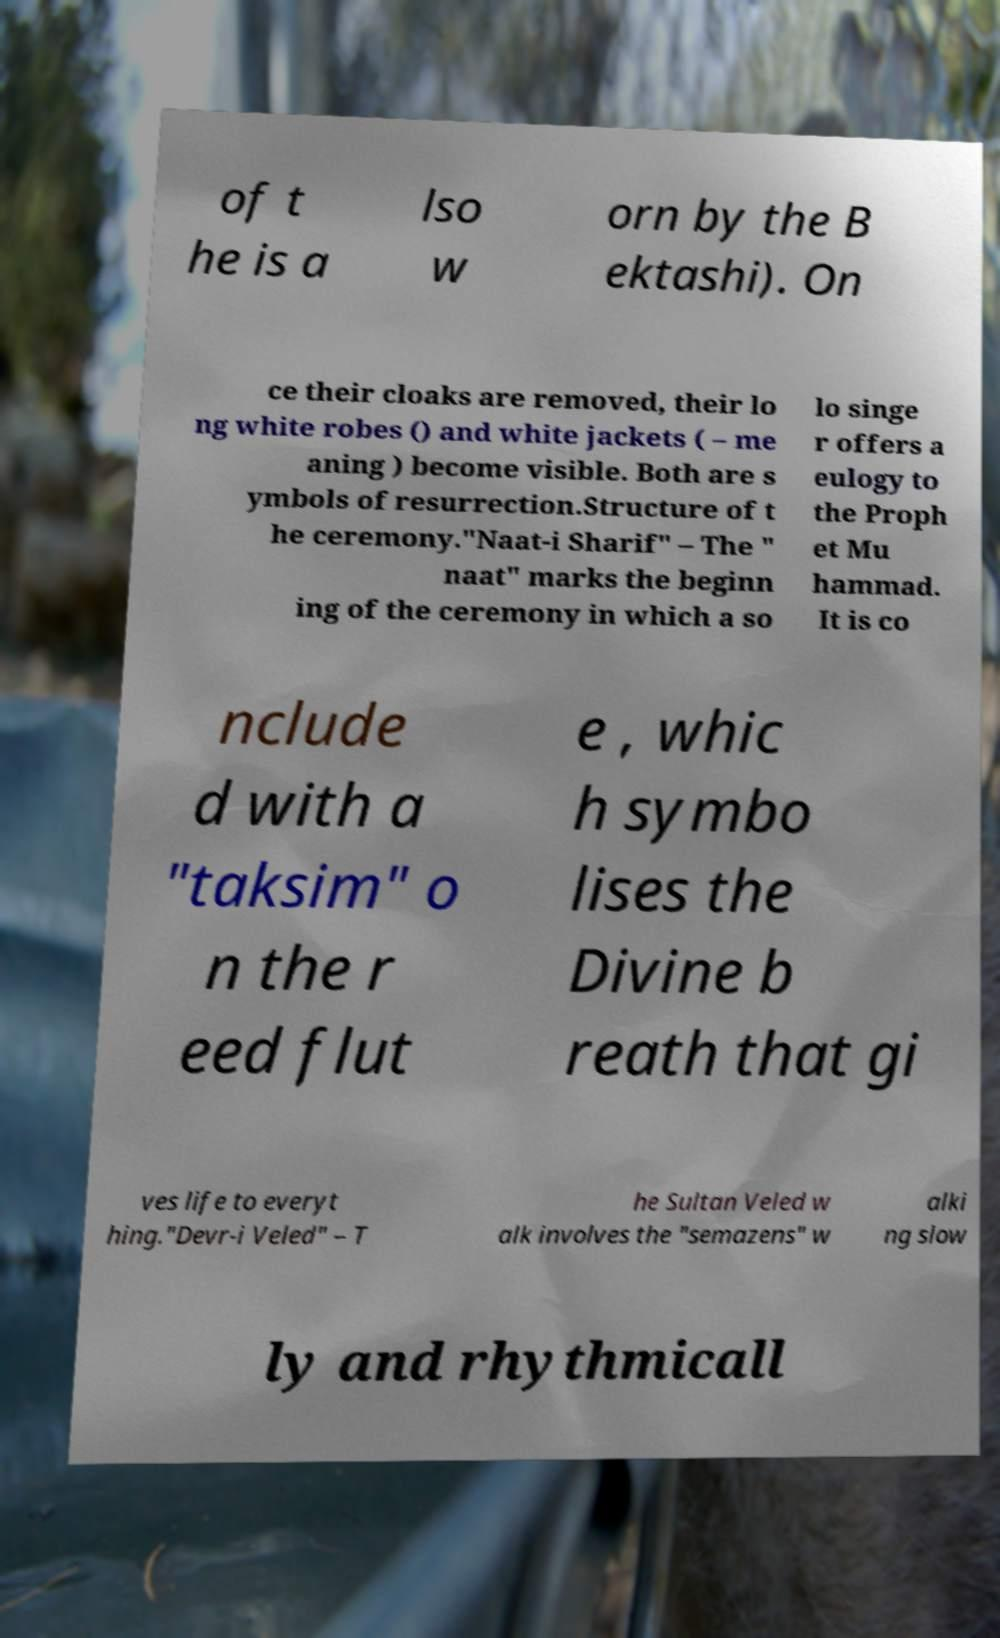For documentation purposes, I need the text within this image transcribed. Could you provide that? of t he is a lso w orn by the B ektashi). On ce their cloaks are removed, their lo ng white robes () and white jackets ( – me aning ) become visible. Both are s ymbols of resurrection.Structure of t he ceremony."Naat-i Sharif" – The " naat" marks the beginn ing of the ceremony in which a so lo singe r offers a eulogy to the Proph et Mu hammad. It is co nclude d with a "taksim" o n the r eed flut e , whic h symbo lises the Divine b reath that gi ves life to everyt hing."Devr-i Veled" – T he Sultan Veled w alk involves the "semazens" w alki ng slow ly and rhythmicall 